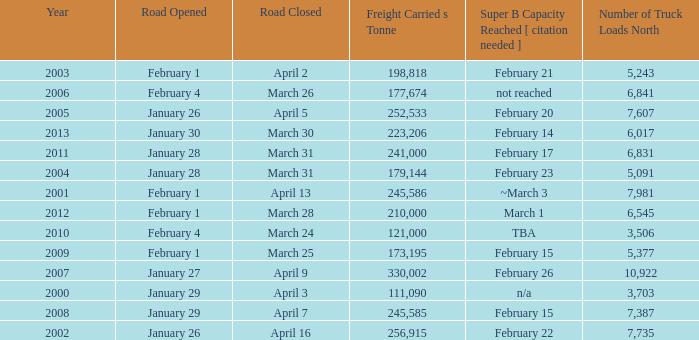What is the smallest amount of freight carried on the road that closed on March 31 and reached super B capacity on February 17 after 2011? None. 